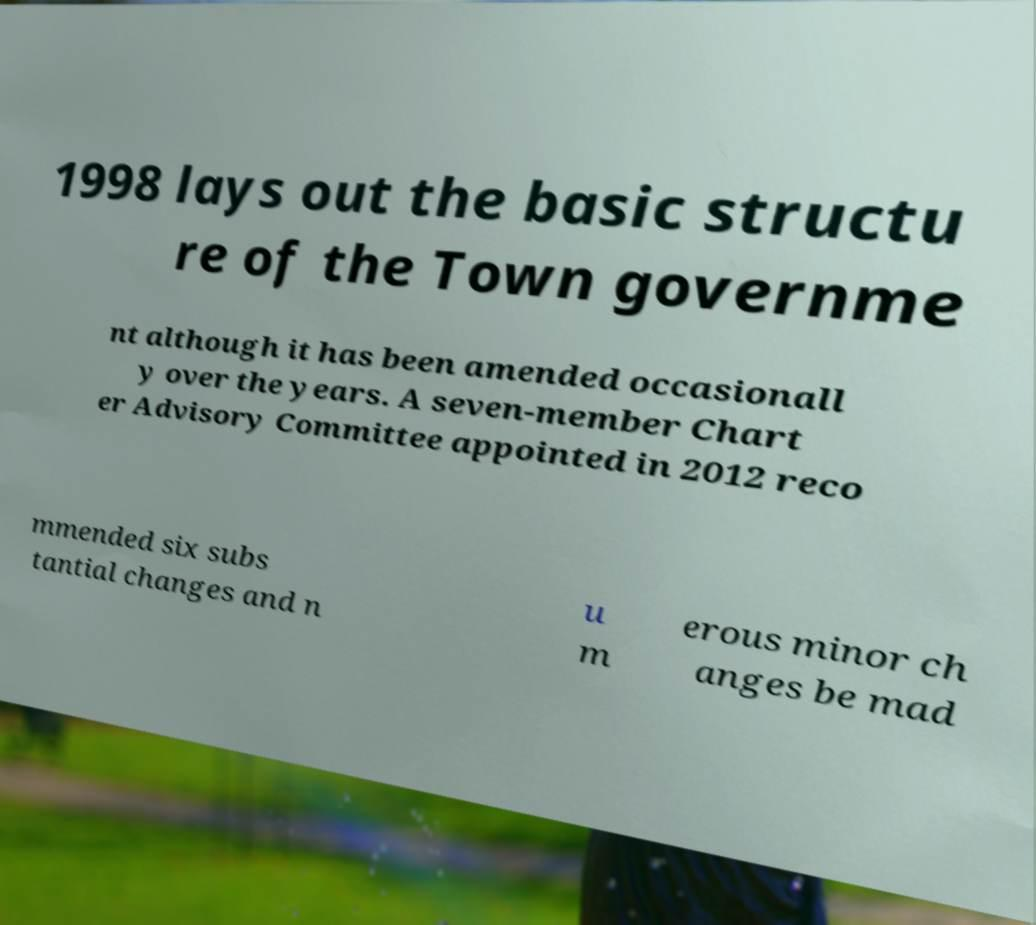Please identify and transcribe the text found in this image. 1998 lays out the basic structu re of the Town governme nt although it has been amended occasionall y over the years. A seven-member Chart er Advisory Committee appointed in 2012 reco mmended six subs tantial changes and n u m erous minor ch anges be mad 